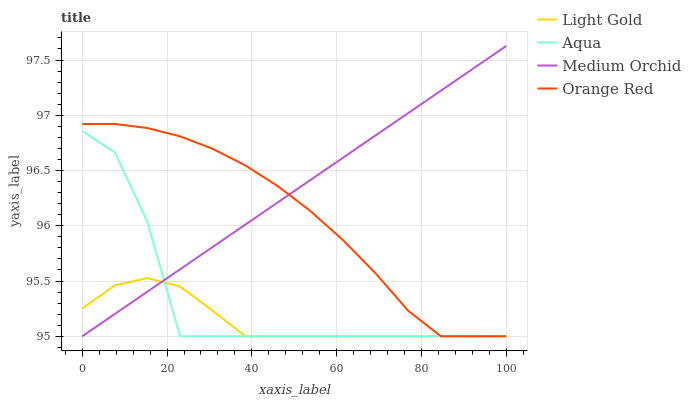Does Light Gold have the minimum area under the curve?
Answer yes or no. Yes. Does Medium Orchid have the maximum area under the curve?
Answer yes or no. Yes. Does Medium Orchid have the minimum area under the curve?
Answer yes or no. No. Does Light Gold have the maximum area under the curve?
Answer yes or no. No. Is Medium Orchid the smoothest?
Answer yes or no. Yes. Is Aqua the roughest?
Answer yes or no. Yes. Is Light Gold the smoothest?
Answer yes or no. No. Is Light Gold the roughest?
Answer yes or no. No. Does Aqua have the lowest value?
Answer yes or no. Yes. Does Medium Orchid have the highest value?
Answer yes or no. Yes. Does Light Gold have the highest value?
Answer yes or no. No. Does Light Gold intersect Orange Red?
Answer yes or no. Yes. Is Light Gold less than Orange Red?
Answer yes or no. No. Is Light Gold greater than Orange Red?
Answer yes or no. No. 